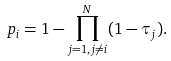<formula> <loc_0><loc_0><loc_500><loc_500>p _ { i } = 1 - \prod _ { j = 1 , j \neq i } ^ { N } ( 1 - \tau _ { j } ) .</formula> 